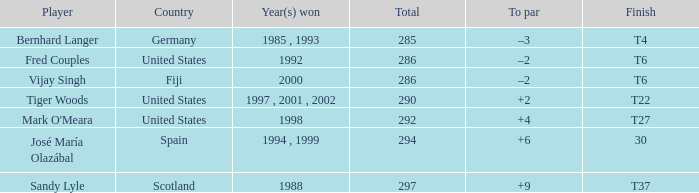Which player possesses a sum exceeding 290 and +4 to par? Mark O'Meara. 